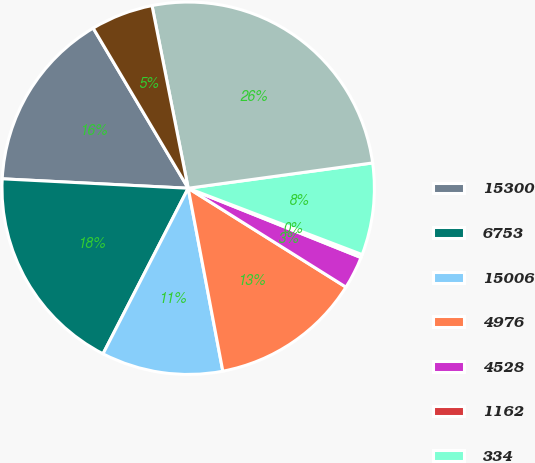Convert chart to OTSL. <chart><loc_0><loc_0><loc_500><loc_500><pie_chart><fcel>15300<fcel>6753<fcel>15006<fcel>4976<fcel>4528<fcel>1162<fcel>334<fcel>66104<fcel>842<nl><fcel>15.67%<fcel>18.24%<fcel>10.54%<fcel>13.11%<fcel>2.84%<fcel>0.27%<fcel>7.97%<fcel>25.94%<fcel>5.41%<nl></chart> 